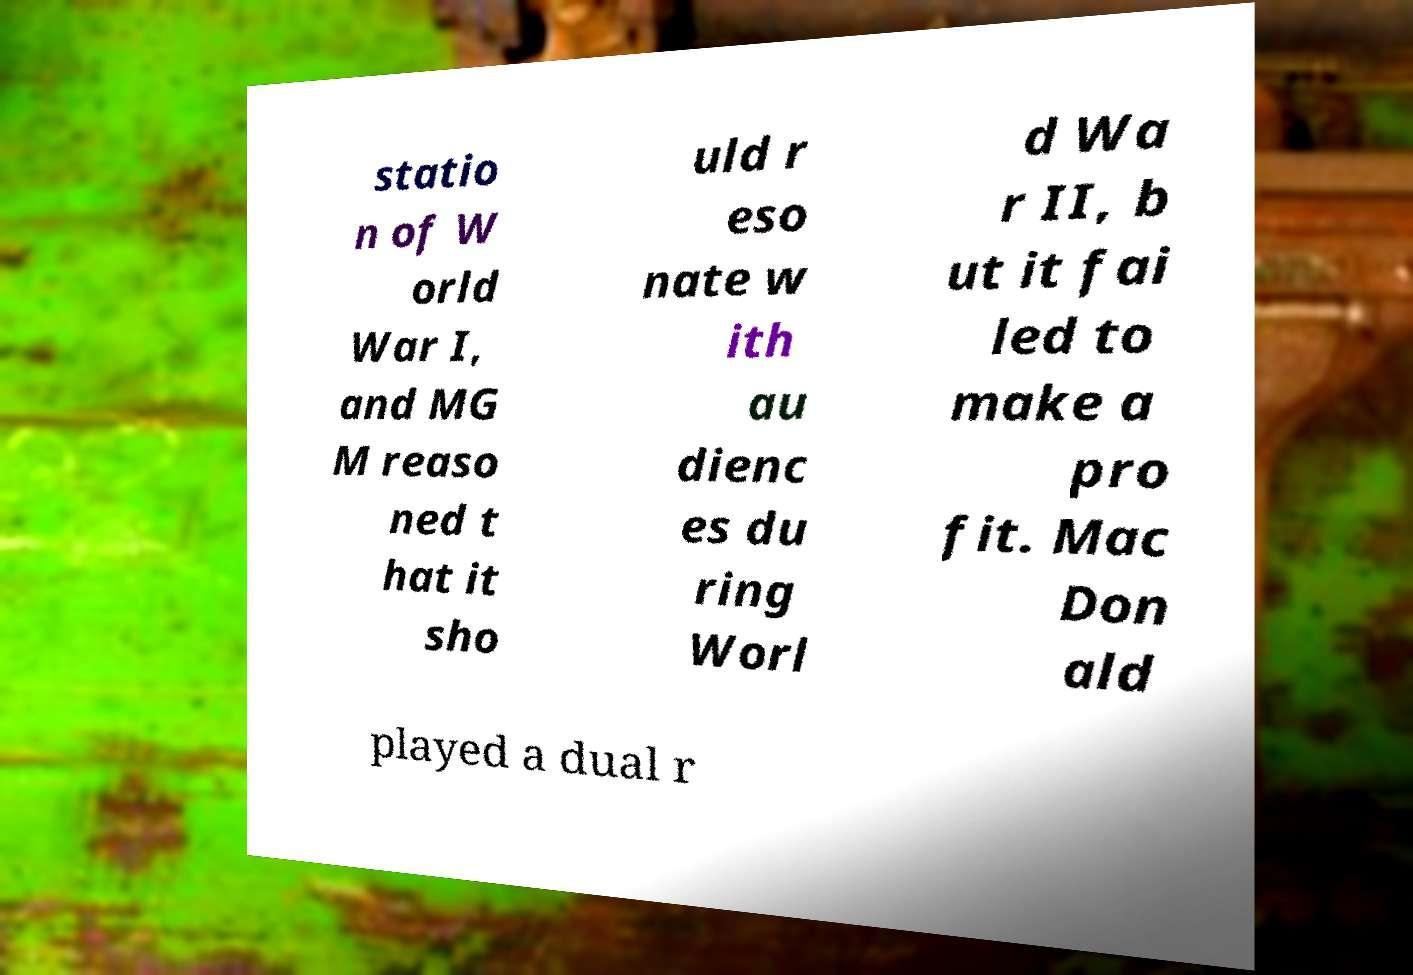Please read and relay the text visible in this image. What does it say? statio n of W orld War I, and MG M reaso ned t hat it sho uld r eso nate w ith au dienc es du ring Worl d Wa r II, b ut it fai led to make a pro fit. Mac Don ald played a dual r 